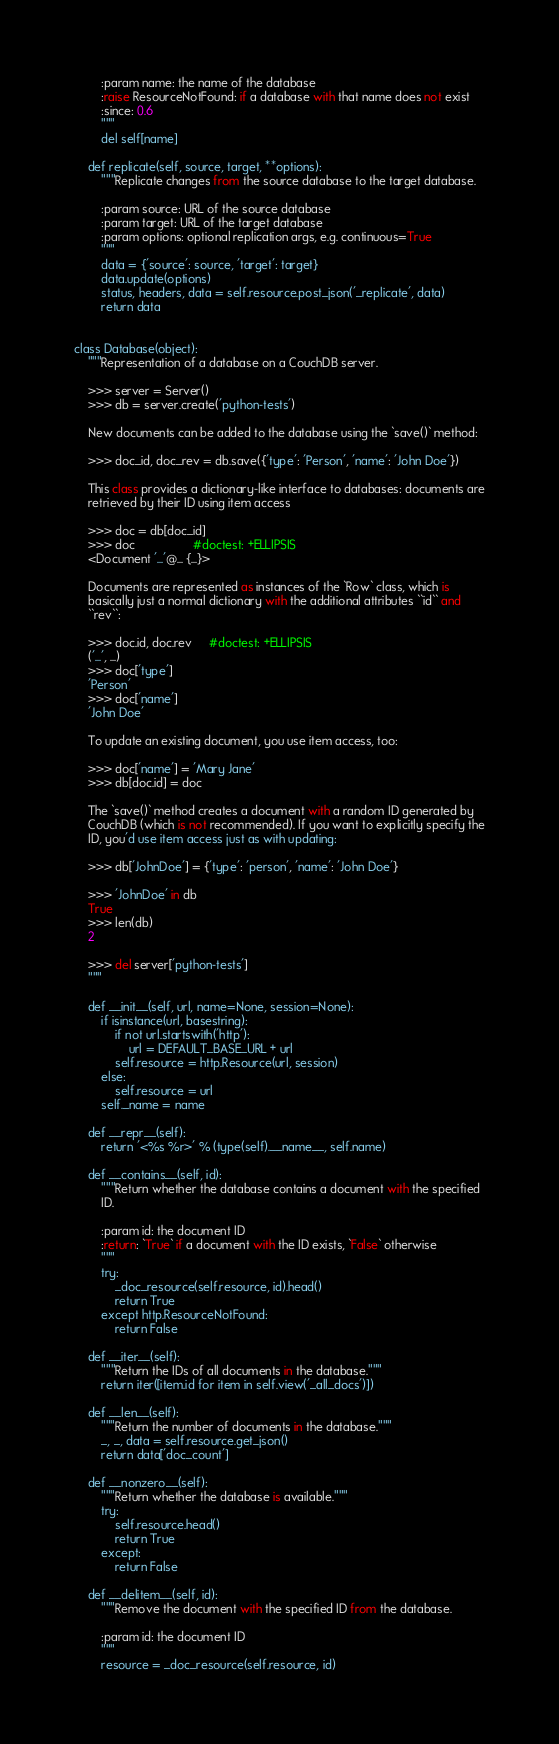<code> <loc_0><loc_0><loc_500><loc_500><_Python_>        :param name: the name of the database
        :raise ResourceNotFound: if a database with that name does not exist
        :since: 0.6
        """
        del self[name]

    def replicate(self, source, target, **options):
        """Replicate changes from the source database to the target database.

        :param source: URL of the source database
        :param target: URL of the target database
        :param options: optional replication args, e.g. continuous=True
        """
        data = {'source': source, 'target': target}
        data.update(options)
        status, headers, data = self.resource.post_json('_replicate', data)
        return data


class Database(object):
    """Representation of a database on a CouchDB server.

    >>> server = Server()
    >>> db = server.create('python-tests')

    New documents can be added to the database using the `save()` method:

    >>> doc_id, doc_rev = db.save({'type': 'Person', 'name': 'John Doe'})

    This class provides a dictionary-like interface to databases: documents are
    retrieved by their ID using item access

    >>> doc = db[doc_id]
    >>> doc                 #doctest: +ELLIPSIS
    <Document '...'@... {...}>

    Documents are represented as instances of the `Row` class, which is
    basically just a normal dictionary with the additional attributes ``id`` and
    ``rev``:

    >>> doc.id, doc.rev     #doctest: +ELLIPSIS
    ('...', ...)
    >>> doc['type']
    'Person'
    >>> doc['name']
    'John Doe'

    To update an existing document, you use item access, too:

    >>> doc['name'] = 'Mary Jane'
    >>> db[doc.id] = doc

    The `save()` method creates a document with a random ID generated by
    CouchDB (which is not recommended). If you want to explicitly specify the
    ID, you'd use item access just as with updating:

    >>> db['JohnDoe'] = {'type': 'person', 'name': 'John Doe'}

    >>> 'JohnDoe' in db
    True
    >>> len(db)
    2

    >>> del server['python-tests']
    """

    def __init__(self, url, name=None, session=None):
        if isinstance(url, basestring):
            if not url.startswith('http'):
                url = DEFAULT_BASE_URL + url
            self.resource = http.Resource(url, session)
        else:
            self.resource = url
        self._name = name

    def __repr__(self):
        return '<%s %r>' % (type(self).__name__, self.name)

    def __contains__(self, id):
        """Return whether the database contains a document with the specified
        ID.

        :param id: the document ID
        :return: `True` if a document with the ID exists, `False` otherwise
        """
        try:
            _doc_resource(self.resource, id).head()
            return True
        except http.ResourceNotFound:
            return False

    def __iter__(self):
        """Return the IDs of all documents in the database."""
        return iter([item.id for item in self.view('_all_docs')])

    def __len__(self):
        """Return the number of documents in the database."""
        _, _, data = self.resource.get_json()
        return data['doc_count']

    def __nonzero__(self):
        """Return whether the database is available."""
        try:
            self.resource.head()
            return True
        except:
            return False

    def __delitem__(self, id):
        """Remove the document with the specified ID from the database.

        :param id: the document ID
        """
        resource = _doc_resource(self.resource, id)</code> 